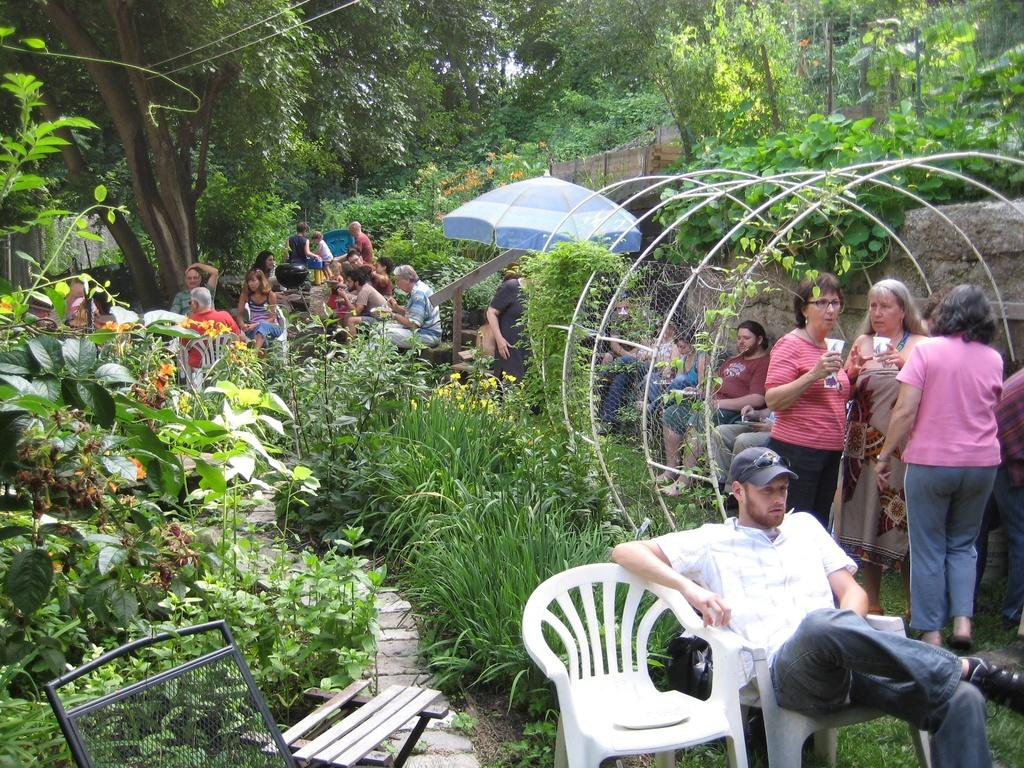How many people are present in the image? There are multiple people in the image. What are some of the people doing in the image? Some of the people are sitting, and some are standing. What type of vegetation can be seen in the image? There are many plants and trees in the image. How long does it take for the creator to jump in the image? There is no creator or jumping depicted in the image. 